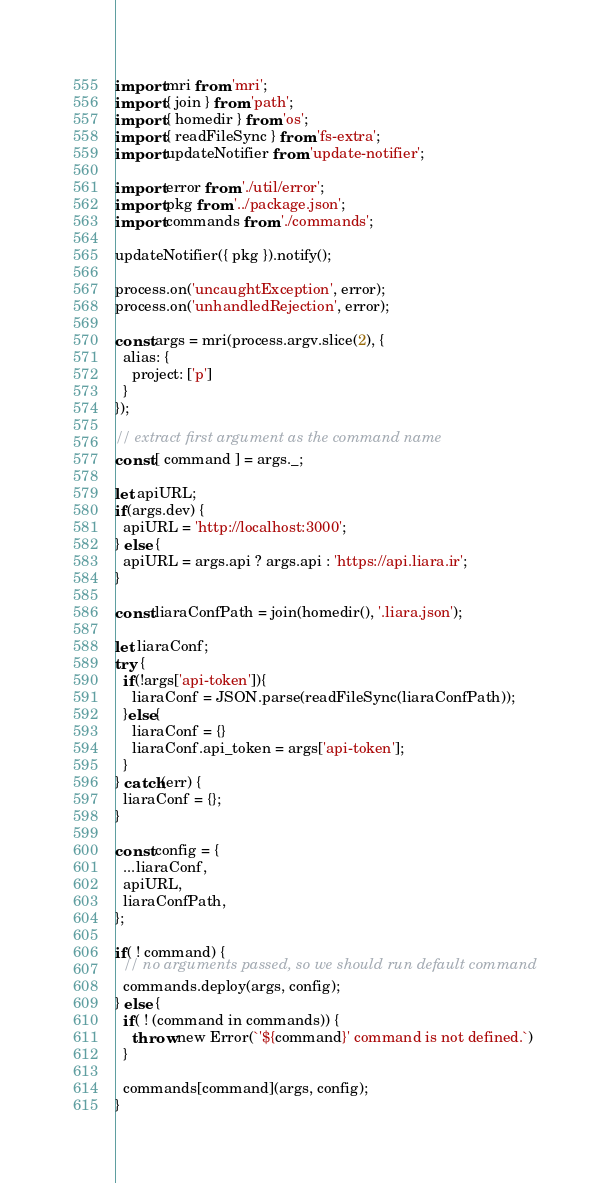<code> <loc_0><loc_0><loc_500><loc_500><_JavaScript_>import mri from 'mri';
import { join } from 'path';
import { homedir } from 'os';
import { readFileSync } from 'fs-extra';
import updateNotifier from 'update-notifier';

import error from './util/error';
import pkg from '../package.json';
import commands from './commands';

updateNotifier({ pkg }).notify();

process.on('uncaughtException', error);
process.on('unhandledRejection', error);

const args = mri(process.argv.slice(2), {
  alias: {
    project: ['p']
  }
});

// extract first argument as the command name
const [ command ] = args._;

let apiURL;
if(args.dev) {
  apiURL = 'http://localhost:3000';
} else {
  apiURL = args.api ? args.api : 'https://api.liara.ir';
}

const liaraConfPath = join(homedir(), '.liara.json');

let liaraConf;
try {
  if(!args['api-token']){
    liaraConf = JSON.parse(readFileSync(liaraConfPath));   
  }else{
    liaraConf = {}
    liaraConf.api_token = args['api-token'];
  }
} catch(err) {
  liaraConf = {};
}

const config = {
  ...liaraConf,
  apiURL,
  liaraConfPath,
};

if( ! command) {
  // no arguments passed, so we should run default command
  commands.deploy(args, config);
} else {
  if( ! (command in commands)) {
    throw new Error(`'${command}' command is not defined.`)
  }

  commands[command](args, config);
}
</code> 